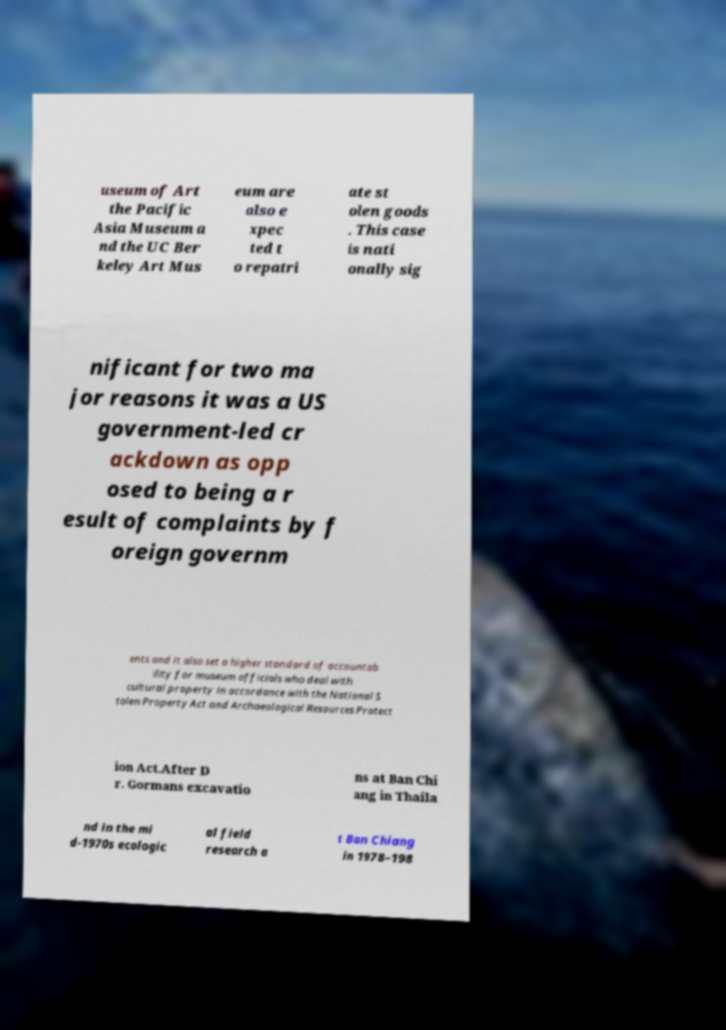Please read and relay the text visible in this image. What does it say? useum of Art the Pacific Asia Museum a nd the UC Ber keley Art Mus eum are also e xpec ted t o repatri ate st olen goods . This case is nati onally sig nificant for two ma jor reasons it was a US government-led cr ackdown as opp osed to being a r esult of complaints by f oreign governm ents and it also set a higher standard of accountab ility for museum officials who deal with cultural property in accordance with the National S tolen Property Act and Archaeological Resources Protect ion Act.After D r. Gormans excavatio ns at Ban Chi ang in Thaila nd in the mi d-1970s ecologic al field research a t Ban Chiang in 1978–198 